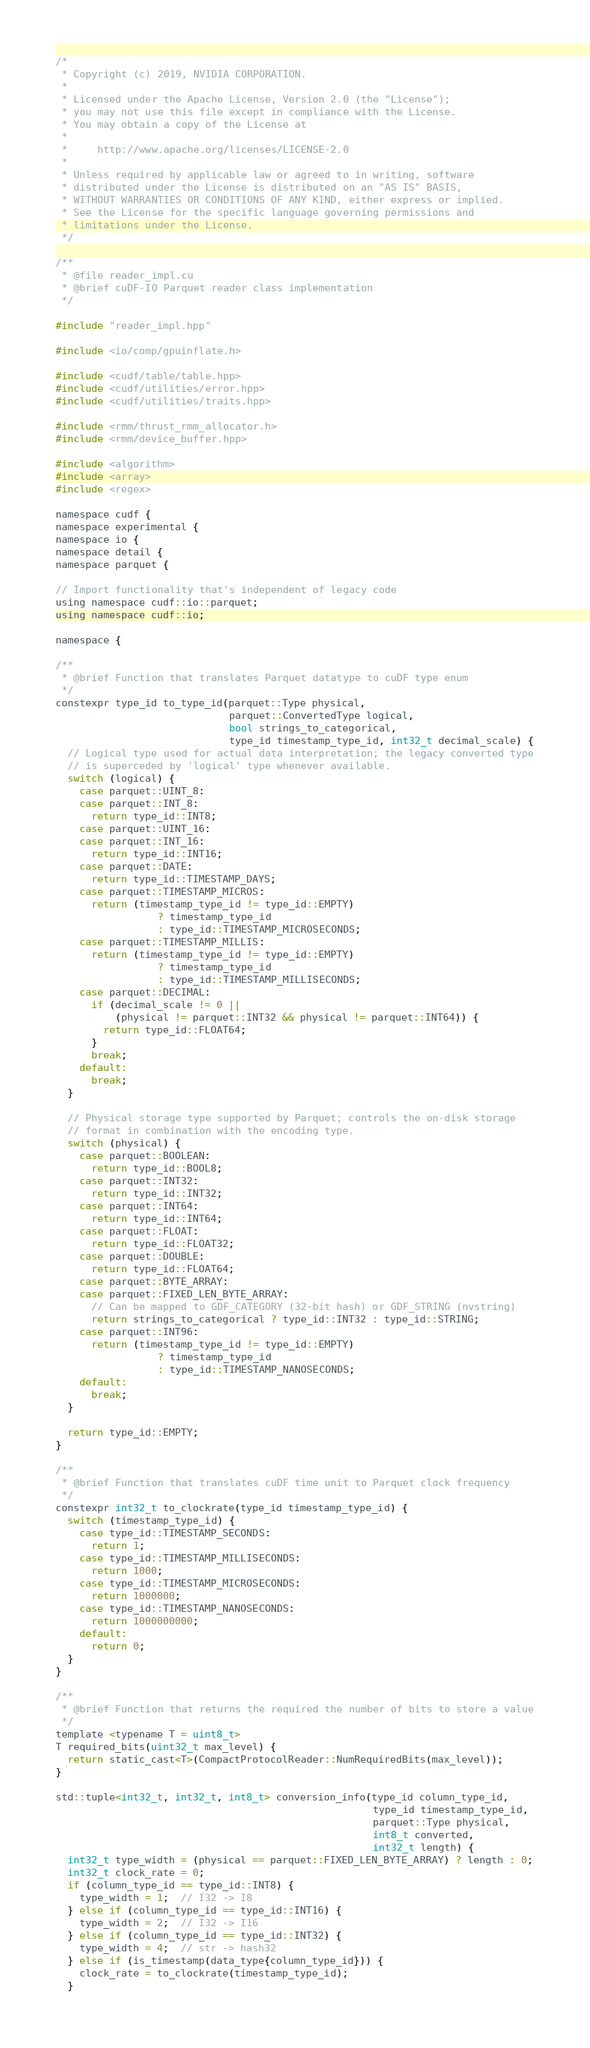Convert code to text. <code><loc_0><loc_0><loc_500><loc_500><_Cuda_>/*
 * Copyright (c) 2019, NVIDIA CORPORATION.
 *
 * Licensed under the Apache License, Version 2.0 (the "License");
 * you may not use this file except in compliance with the License.
 * You may obtain a copy of the License at
 *
 *     http://www.apache.org/licenses/LICENSE-2.0
 *
 * Unless required by applicable law or agreed to in writing, software
 * distributed under the License is distributed on an "AS IS" BASIS,
 * WITHOUT WARRANTIES OR CONDITIONS OF ANY KIND, either express or implied.
 * See the License for the specific language governing permissions and
 * limitations under the License.
 */

/**
 * @file reader_impl.cu
 * @brief cuDF-IO Parquet reader class implementation
 */

#include "reader_impl.hpp"

#include <io/comp/gpuinflate.h>

#include <cudf/table/table.hpp>
#include <cudf/utilities/error.hpp>
#include <cudf/utilities/traits.hpp>

#include <rmm/thrust_rmm_allocator.h>
#include <rmm/device_buffer.hpp>

#include <algorithm>
#include <array>
#include <regex>

namespace cudf {
namespace experimental {
namespace io {
namespace detail {
namespace parquet {

// Import functionality that's independent of legacy code
using namespace cudf::io::parquet;
using namespace cudf::io;

namespace {

/**
 * @brief Function that translates Parquet datatype to cuDF type enum
 */
constexpr type_id to_type_id(parquet::Type physical,
                             parquet::ConvertedType logical,
                             bool strings_to_categorical,
                             type_id timestamp_type_id, int32_t decimal_scale) {
  // Logical type used for actual data interpretation; the legacy converted type
  // is superceded by 'logical' type whenever available.
  switch (logical) {
    case parquet::UINT_8:
    case parquet::INT_8:
      return type_id::INT8;
    case parquet::UINT_16:
    case parquet::INT_16:
      return type_id::INT16;
    case parquet::DATE:
      return type_id::TIMESTAMP_DAYS;
    case parquet::TIMESTAMP_MICROS:
      return (timestamp_type_id != type_id::EMPTY)
                 ? timestamp_type_id
                 : type_id::TIMESTAMP_MICROSECONDS;
    case parquet::TIMESTAMP_MILLIS:
      return (timestamp_type_id != type_id::EMPTY)
                 ? timestamp_type_id
                 : type_id::TIMESTAMP_MILLISECONDS;
    case parquet::DECIMAL:
      if (decimal_scale != 0 ||
          (physical != parquet::INT32 && physical != parquet::INT64)) {
        return type_id::FLOAT64;
      }
      break;
    default:
      break;
  }

  // Physical storage type supported by Parquet; controls the on-disk storage
  // format in combination with the encoding type.
  switch (physical) {
    case parquet::BOOLEAN:
      return type_id::BOOL8;
    case parquet::INT32:
      return type_id::INT32;
    case parquet::INT64:
      return type_id::INT64;
    case parquet::FLOAT:
      return type_id::FLOAT32;
    case parquet::DOUBLE:
      return type_id::FLOAT64;
    case parquet::BYTE_ARRAY:
    case parquet::FIXED_LEN_BYTE_ARRAY:
      // Can be mapped to GDF_CATEGORY (32-bit hash) or GDF_STRING (nvstring)
      return strings_to_categorical ? type_id::INT32 : type_id::STRING;
    case parquet::INT96:
      return (timestamp_type_id != type_id::EMPTY)
                 ? timestamp_type_id
                 : type_id::TIMESTAMP_NANOSECONDS;
    default:
      break;
  }

  return type_id::EMPTY;
}

/**
 * @brief Function that translates cuDF time unit to Parquet clock frequency
 */
constexpr int32_t to_clockrate(type_id timestamp_type_id) {
  switch (timestamp_type_id) {
    case type_id::TIMESTAMP_SECONDS:
      return 1;
    case type_id::TIMESTAMP_MILLISECONDS:
      return 1000;
    case type_id::TIMESTAMP_MICROSECONDS:
      return 1000000;
    case type_id::TIMESTAMP_NANOSECONDS:
      return 1000000000;
    default:
      return 0;
  }
}

/**
 * @brief Function that returns the required the number of bits to store a value
 */
template <typename T = uint8_t>
T required_bits(uint32_t max_level) {
  return static_cast<T>(CompactProtocolReader::NumRequiredBits(max_level));
}

std::tuple<int32_t, int32_t, int8_t> conversion_info(type_id column_type_id,
                                                     type_id timestamp_type_id,
                                                     parquet::Type physical,
                                                     int8_t converted,
                                                     int32_t length) {
  int32_t type_width = (physical == parquet::FIXED_LEN_BYTE_ARRAY) ? length : 0;
  int32_t clock_rate = 0;
  if (column_type_id == type_id::INT8) {
    type_width = 1;  // I32 -> I8
  } else if (column_type_id == type_id::INT16) {
    type_width = 2;  // I32 -> I16
  } else if (column_type_id == type_id::INT32) {
    type_width = 4;  // str -> hash32
  } else if (is_timestamp(data_type{column_type_id})) {
    clock_rate = to_clockrate(timestamp_type_id);
  }
</code> 